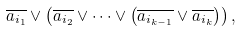Convert formula to latex. <formula><loc_0><loc_0><loc_500><loc_500>\overline { a _ { i _ { 1 } } } \vee \left ( \overline { a _ { i _ { 2 } } } \vee \dots \vee \left ( \overline { a _ { i _ { k - 1 } } } \vee \overline { a _ { i _ { k } } } \right ) \right ) ,</formula> 